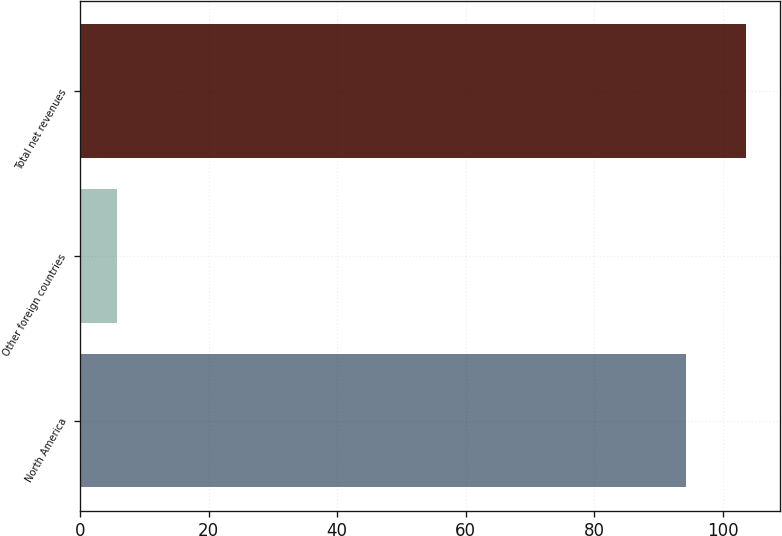<chart> <loc_0><loc_0><loc_500><loc_500><bar_chart><fcel>North America<fcel>Other foreign countries<fcel>Total net revenues<nl><fcel>94.3<fcel>5.7<fcel>103.73<nl></chart> 